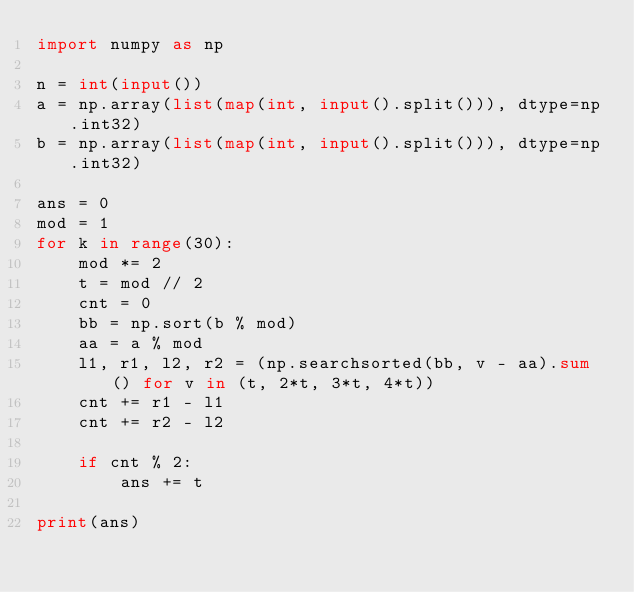<code> <loc_0><loc_0><loc_500><loc_500><_Python_>import numpy as np

n = int(input())
a = np.array(list(map(int, input().split())), dtype=np.int32)
b = np.array(list(map(int, input().split())), dtype=np.int32)

ans = 0
mod = 1
for k in range(30):
    mod *= 2
    t = mod // 2
    cnt = 0
    bb = np.sort(b % mod)
    aa = a % mod
    l1, r1, l2, r2 = (np.searchsorted(bb, v - aa).sum() for v in (t, 2*t, 3*t, 4*t))
    cnt += r1 - l1
    cnt += r2 - l2

    if cnt % 2:
        ans += t

print(ans)
</code> 